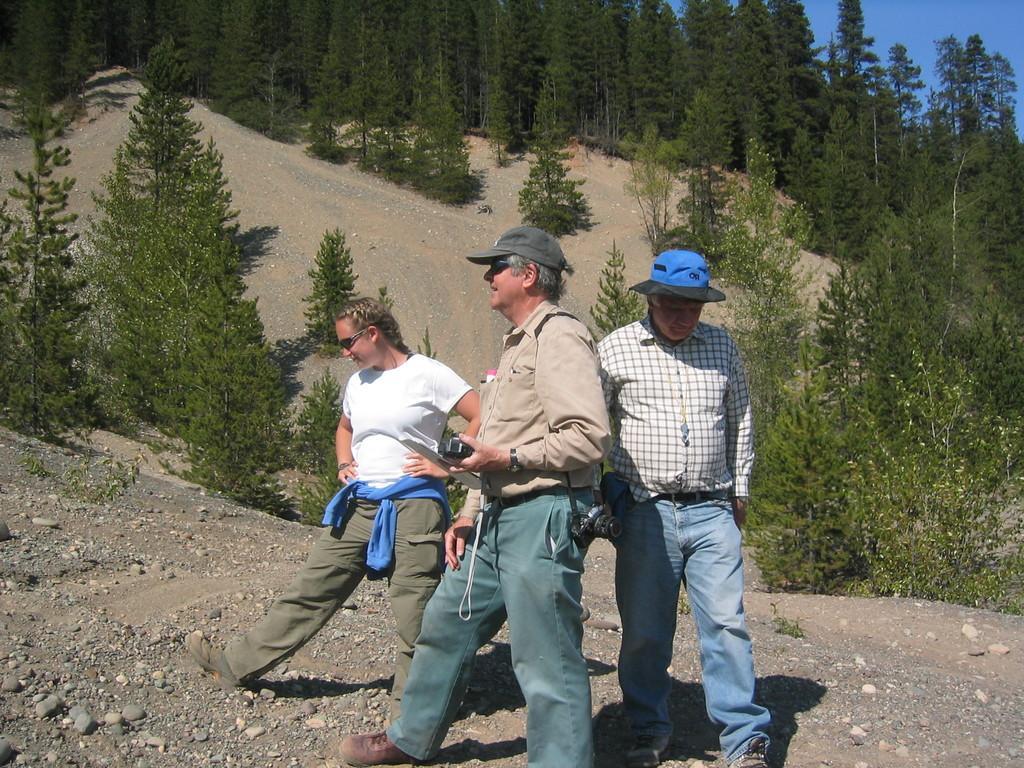Describe this image in one or two sentences. In this image two men and a woman are standing on the land. Men are wearing caps. The person in the middle of the image is holding a camera. Left side there is a woman wearing goggles. Background there are few trees on the land. Right top there is sky. 